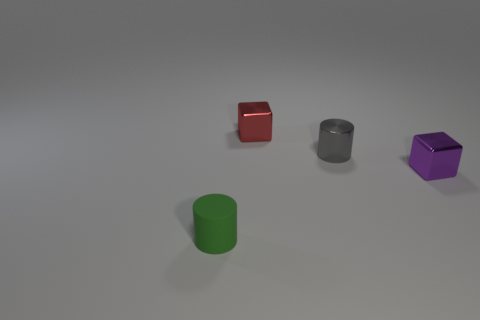Are there any other things that are the same material as the green object?
Your answer should be compact. No. Is the purple cube made of the same material as the small cylinder that is to the right of the green object?
Your answer should be compact. Yes. Is there another gray thing of the same shape as the rubber thing?
Your answer should be compact. Yes. There is a green thing that is the same size as the metal cylinder; what material is it?
Provide a short and direct response. Rubber. There is a shiny cube that is right of the gray metal cylinder; what size is it?
Give a very brief answer. Small. Does the block on the right side of the tiny red block have the same size as the metal cube behind the small purple object?
Your answer should be very brief. Yes. How many green cylinders have the same material as the red block?
Offer a very short reply. 0. What is the color of the tiny rubber cylinder?
Offer a very short reply. Green. There is a purple thing; are there any purple metal things right of it?
Ensure brevity in your answer.  No. Is the tiny rubber cylinder the same color as the metallic cylinder?
Make the answer very short. No. 